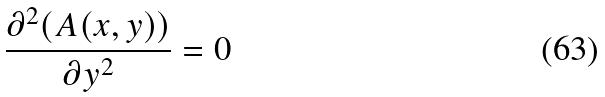Convert formula to latex. <formula><loc_0><loc_0><loc_500><loc_500>\frac { \partial ^ { 2 } ( A ( x , y ) ) } { \partial y ^ { 2 } } = 0</formula> 